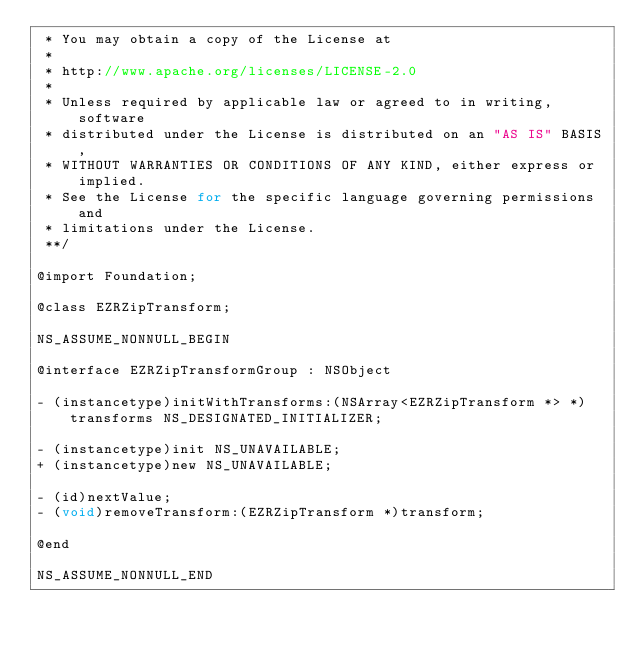<code> <loc_0><loc_0><loc_500><loc_500><_C_> * You may obtain a copy of the License at
 *
 * http://www.apache.org/licenses/LICENSE-2.0
 *
 * Unless required by applicable law or agreed to in writing, software
 * distributed under the License is distributed on an "AS IS" BASIS,
 * WITHOUT WARRANTIES OR CONDITIONS OF ANY KIND, either express or implied.
 * See the License for the specific language governing permissions and
 * limitations under the License.
 **/

@import Foundation;

@class EZRZipTransform;

NS_ASSUME_NONNULL_BEGIN

@interface EZRZipTransformGroup : NSObject

- (instancetype)initWithTransforms:(NSArray<EZRZipTransform *> *)transforms NS_DESIGNATED_INITIALIZER;

- (instancetype)init NS_UNAVAILABLE;
+ (instancetype)new NS_UNAVAILABLE;

- (id)nextValue;
- (void)removeTransform:(EZRZipTransform *)transform;

@end

NS_ASSUME_NONNULL_END
</code> 